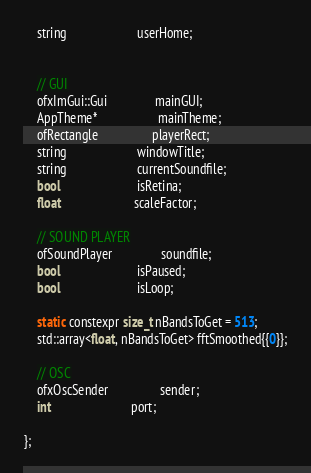Convert code to text. <code><loc_0><loc_0><loc_500><loc_500><_C_>    string                      userHome;


    // GUI
    ofxImGui::Gui               mainGUI;
    AppTheme*                   mainTheme;
    ofRectangle                 playerRect;
    string                      windowTitle;
    string                      currentSoundfile;
    bool                        isRetina;
    float                       scaleFactor;

    // SOUND PLAYER
    ofSoundPlayer               soundfile;
    bool                        isPaused;
    bool                        isLoop;

    static constexpr size_t nBandsToGet = 513;
    std::array<float, nBandsToGet> fftSmoothed{{0}};

    // OSC
    ofxOscSender                sender;
    int                         port;

};
</code> 